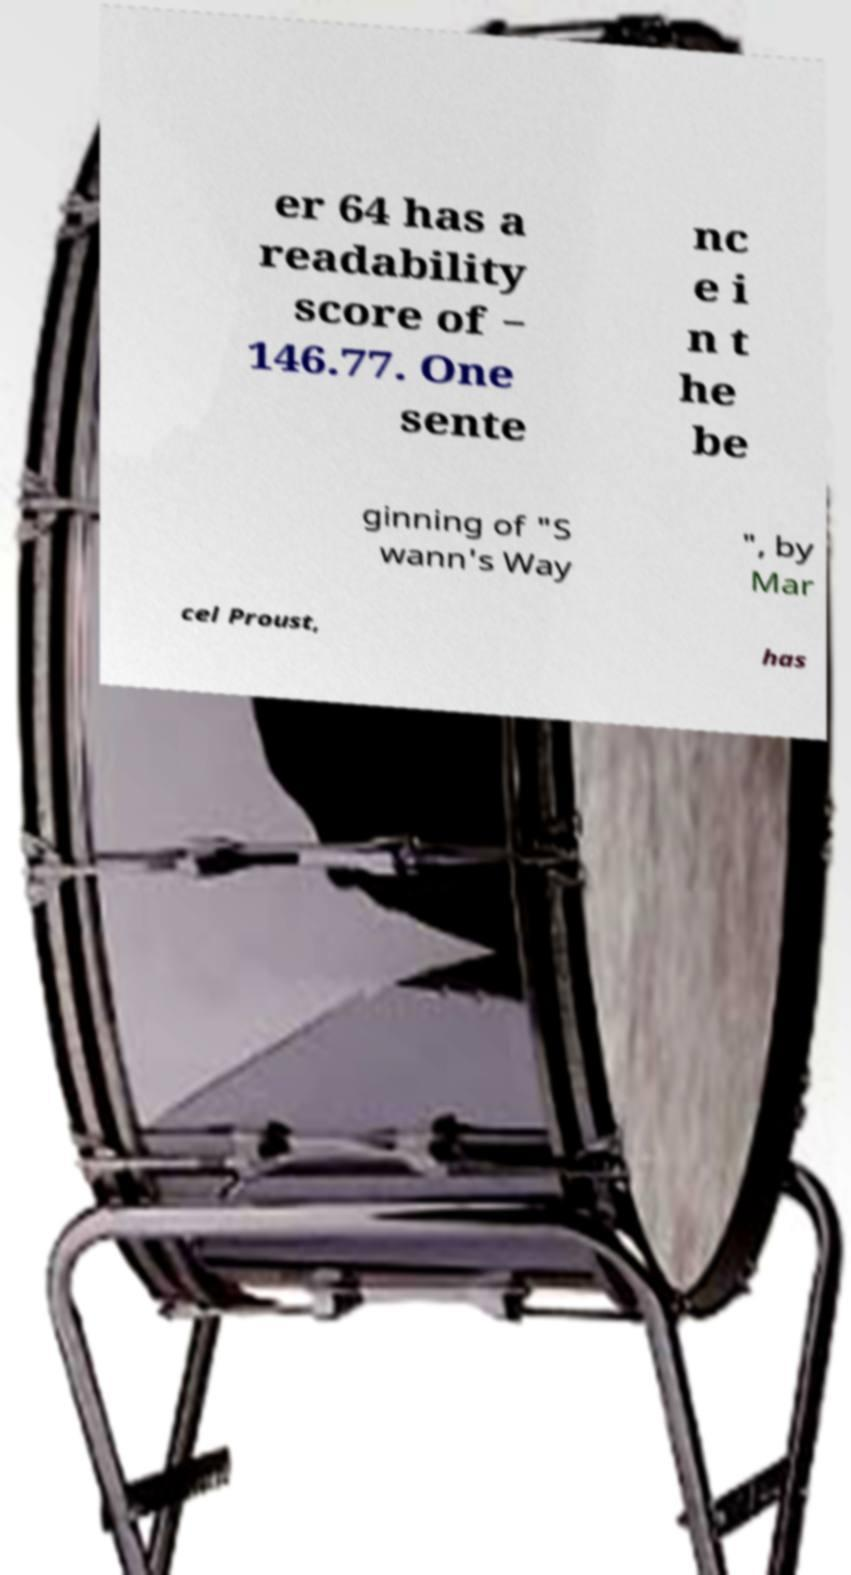Please identify and transcribe the text found in this image. er 64 has a readability score of − 146.77. One sente nc e i n t he be ginning of "S wann's Way ", by Mar cel Proust, has 